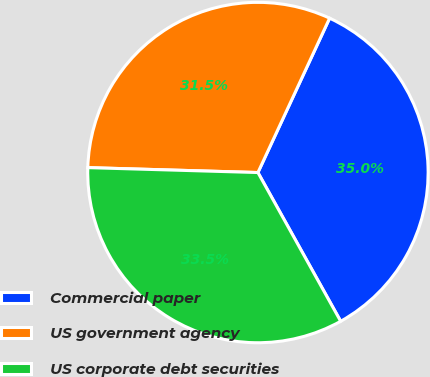Convert chart to OTSL. <chart><loc_0><loc_0><loc_500><loc_500><pie_chart><fcel>Commercial paper<fcel>US government agency<fcel>US corporate debt securities<nl><fcel>35.0%<fcel>31.46%<fcel>33.54%<nl></chart> 